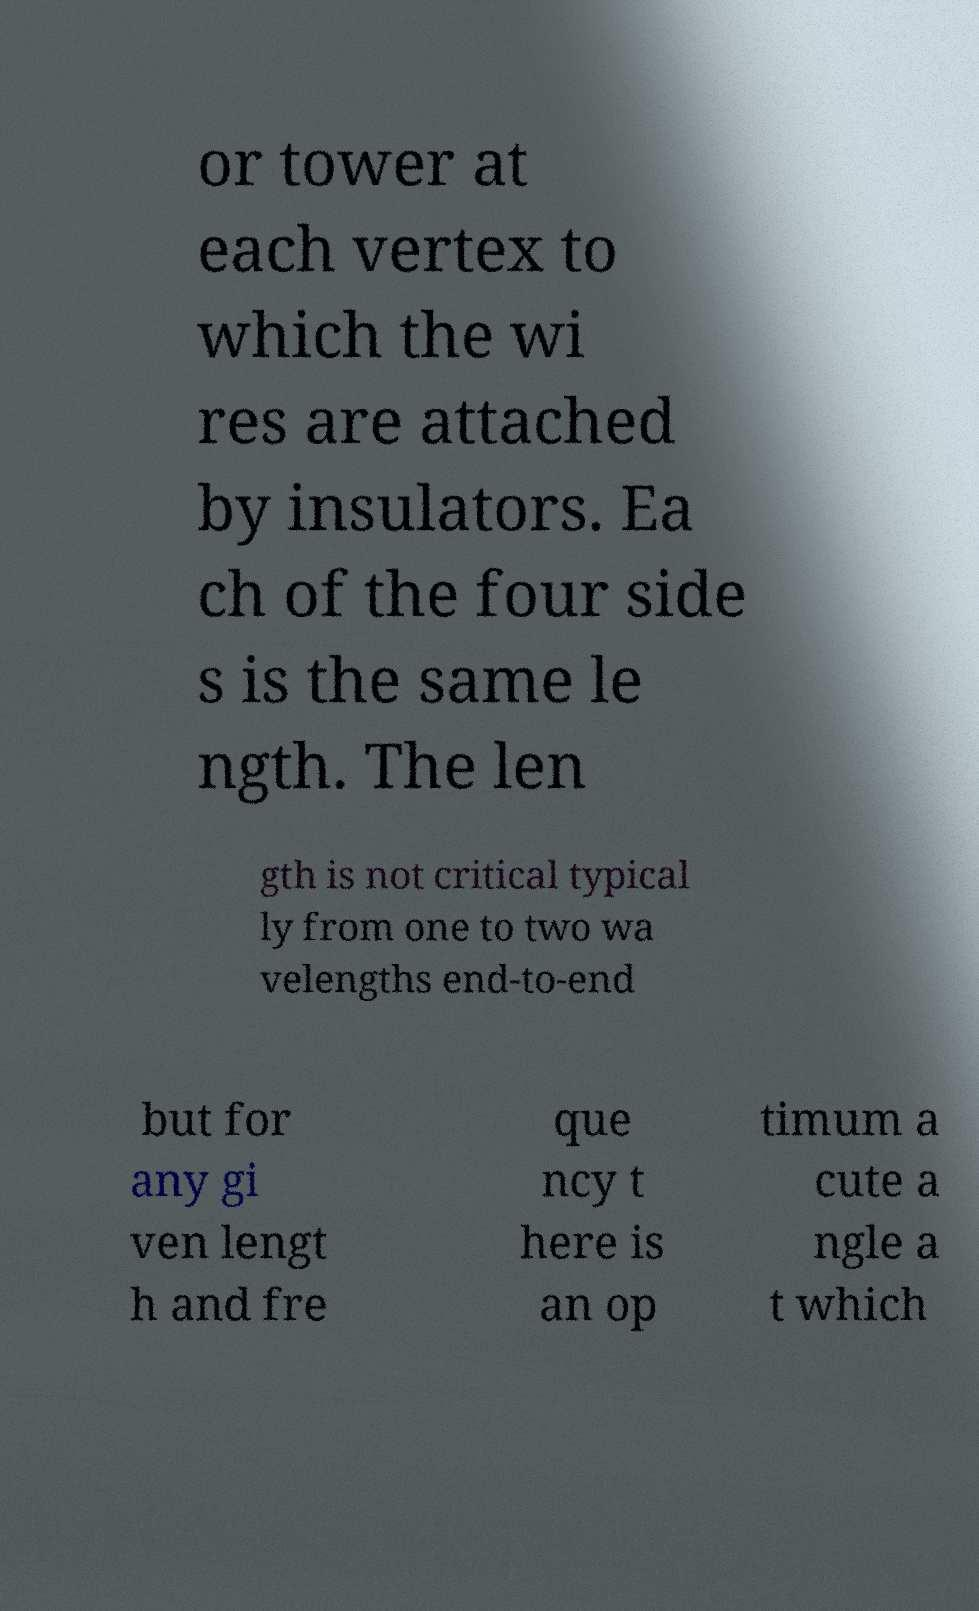For documentation purposes, I need the text within this image transcribed. Could you provide that? or tower at each vertex to which the wi res are attached by insulators. Ea ch of the four side s is the same le ngth. The len gth is not critical typical ly from one to two wa velengths end-to-end but for any gi ven lengt h and fre que ncy t here is an op timum a cute a ngle a t which 